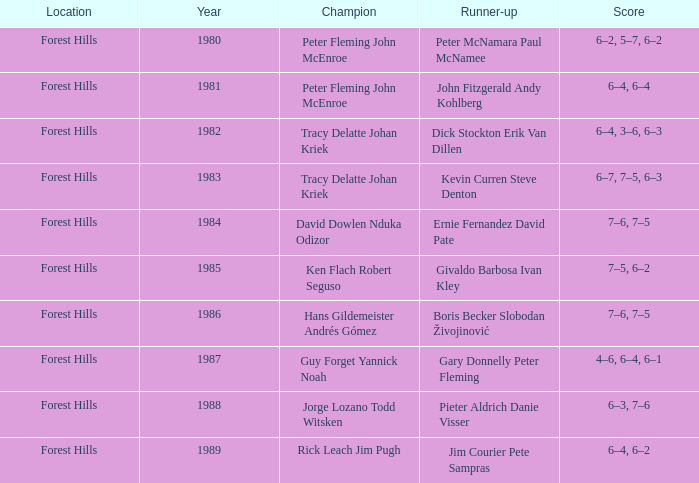Who finished as the second-best in 1989? Jim Courier Pete Sampras. 